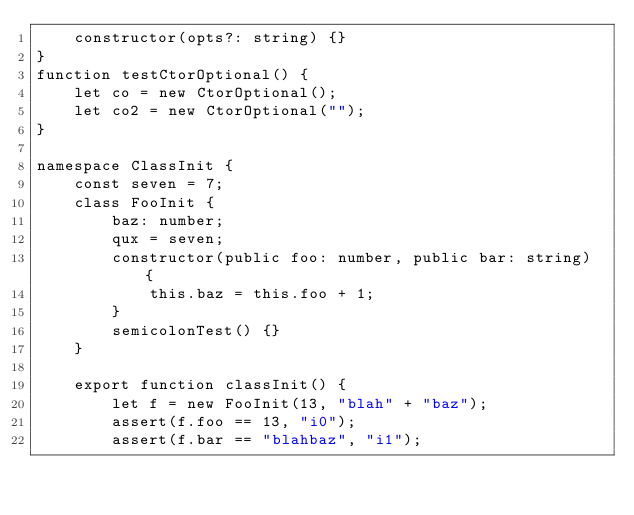Convert code to text. <code><loc_0><loc_0><loc_500><loc_500><_TypeScript_>    constructor(opts?: string) {}
}
function testCtorOptional() {
    let co = new CtorOptional();
    let co2 = new CtorOptional("");
}

namespace ClassInit {
    const seven = 7;
    class FooInit {
        baz: number;
        qux = seven;
        constructor(public foo: number, public bar: string) {
            this.baz = this.foo + 1;
        }
        semicolonTest() {}
    }

    export function classInit() {
        let f = new FooInit(13, "blah" + "baz");
        assert(f.foo == 13, "i0");
        assert(f.bar == "blahbaz", "i1");</code> 